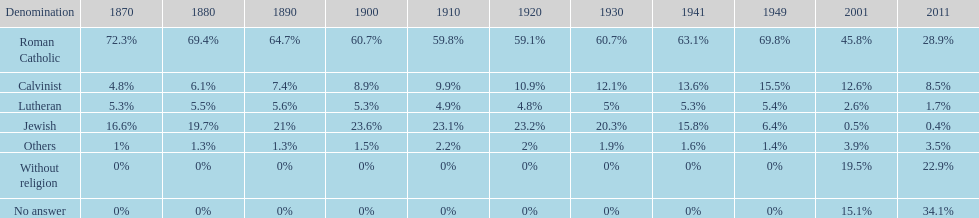In 2011, what was the overall percentage of individuals claiming a religious affiliation? 43%. 